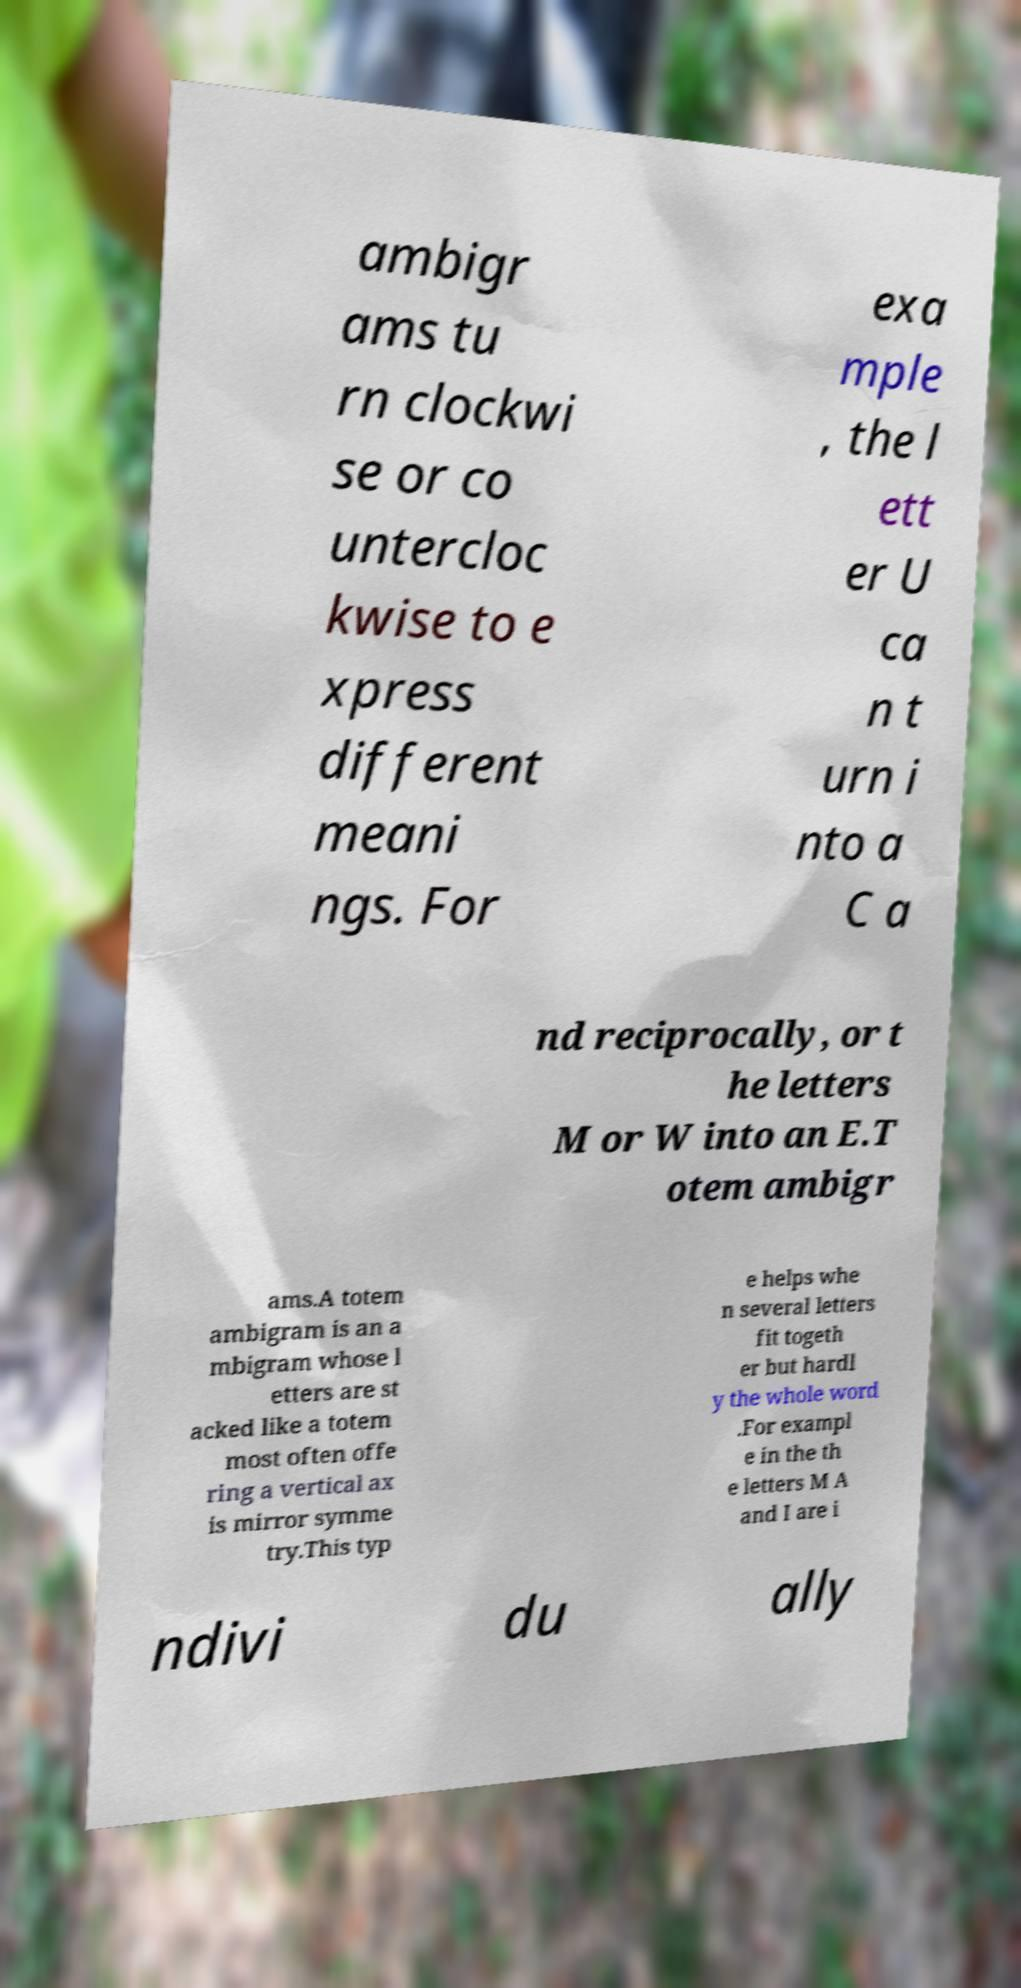I need the written content from this picture converted into text. Can you do that? ambigr ams tu rn clockwi se or co untercloc kwise to e xpress different meani ngs. For exa mple , the l ett er U ca n t urn i nto a C a nd reciprocally, or t he letters M or W into an E.T otem ambigr ams.A totem ambigram is an a mbigram whose l etters are st acked like a totem most often offe ring a vertical ax is mirror symme try.This typ e helps whe n several letters fit togeth er but hardl y the whole word .For exampl e in the th e letters M A and I are i ndivi du ally 